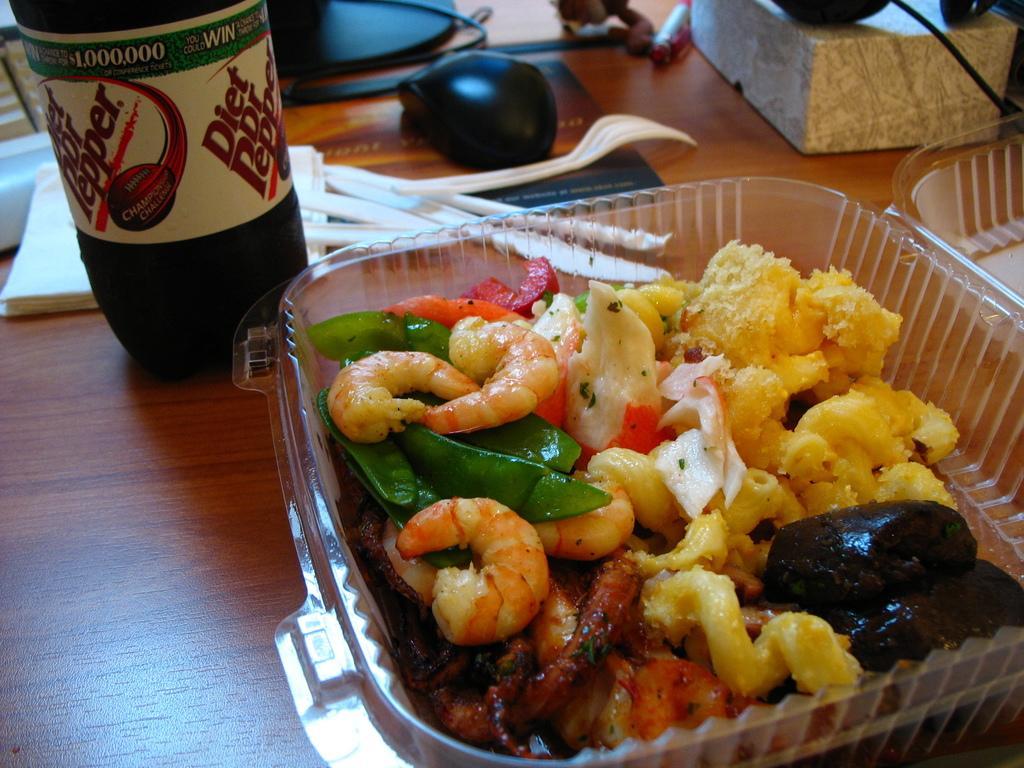In one or two sentences, can you explain what this image depicts? In this image I can see a table and on it I can see a plastic box, a bottle, a fork, a knife, few tissue papers, a mouse and few other stuffs. I can also see different types of food in the box. 